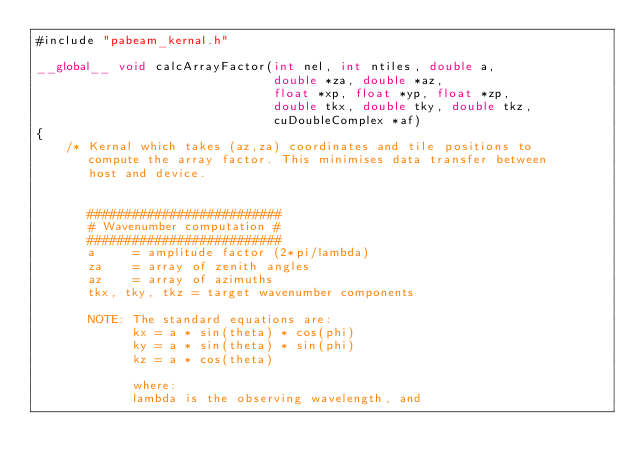<code> <loc_0><loc_0><loc_500><loc_500><_Cuda_>#include "pabeam_kernal.h"

__global__ void calcArrayFactor(int nel, int ntiles, double a, 
                                double *za, double *az, 
                                float *xp, float *yp, float *zp, 
                                double tkx, double tky, double tkz, 
                                cuDoubleComplex *af)
{
    /* Kernal which takes (az,za) coordinates and tile positions to 
       compute the array factor. This minimises data transfer between 
       host and device.
   

       ##########################
       # Wavenumber computation #
       ##########################
       a     = amplitude factor (2*pi/lambda)
       za    = array of zenith angles
       az    = array of azimuths
       tkx, tky, tkz = target wavenumber components

       NOTE: The standard equations are:
             kx = a * sin(theta) * cos(phi)
             ky = a * sin(theta) * sin(phi)
             kz = a * cos(theta)

             where:
             lambda is the observing wavelength, and</code> 